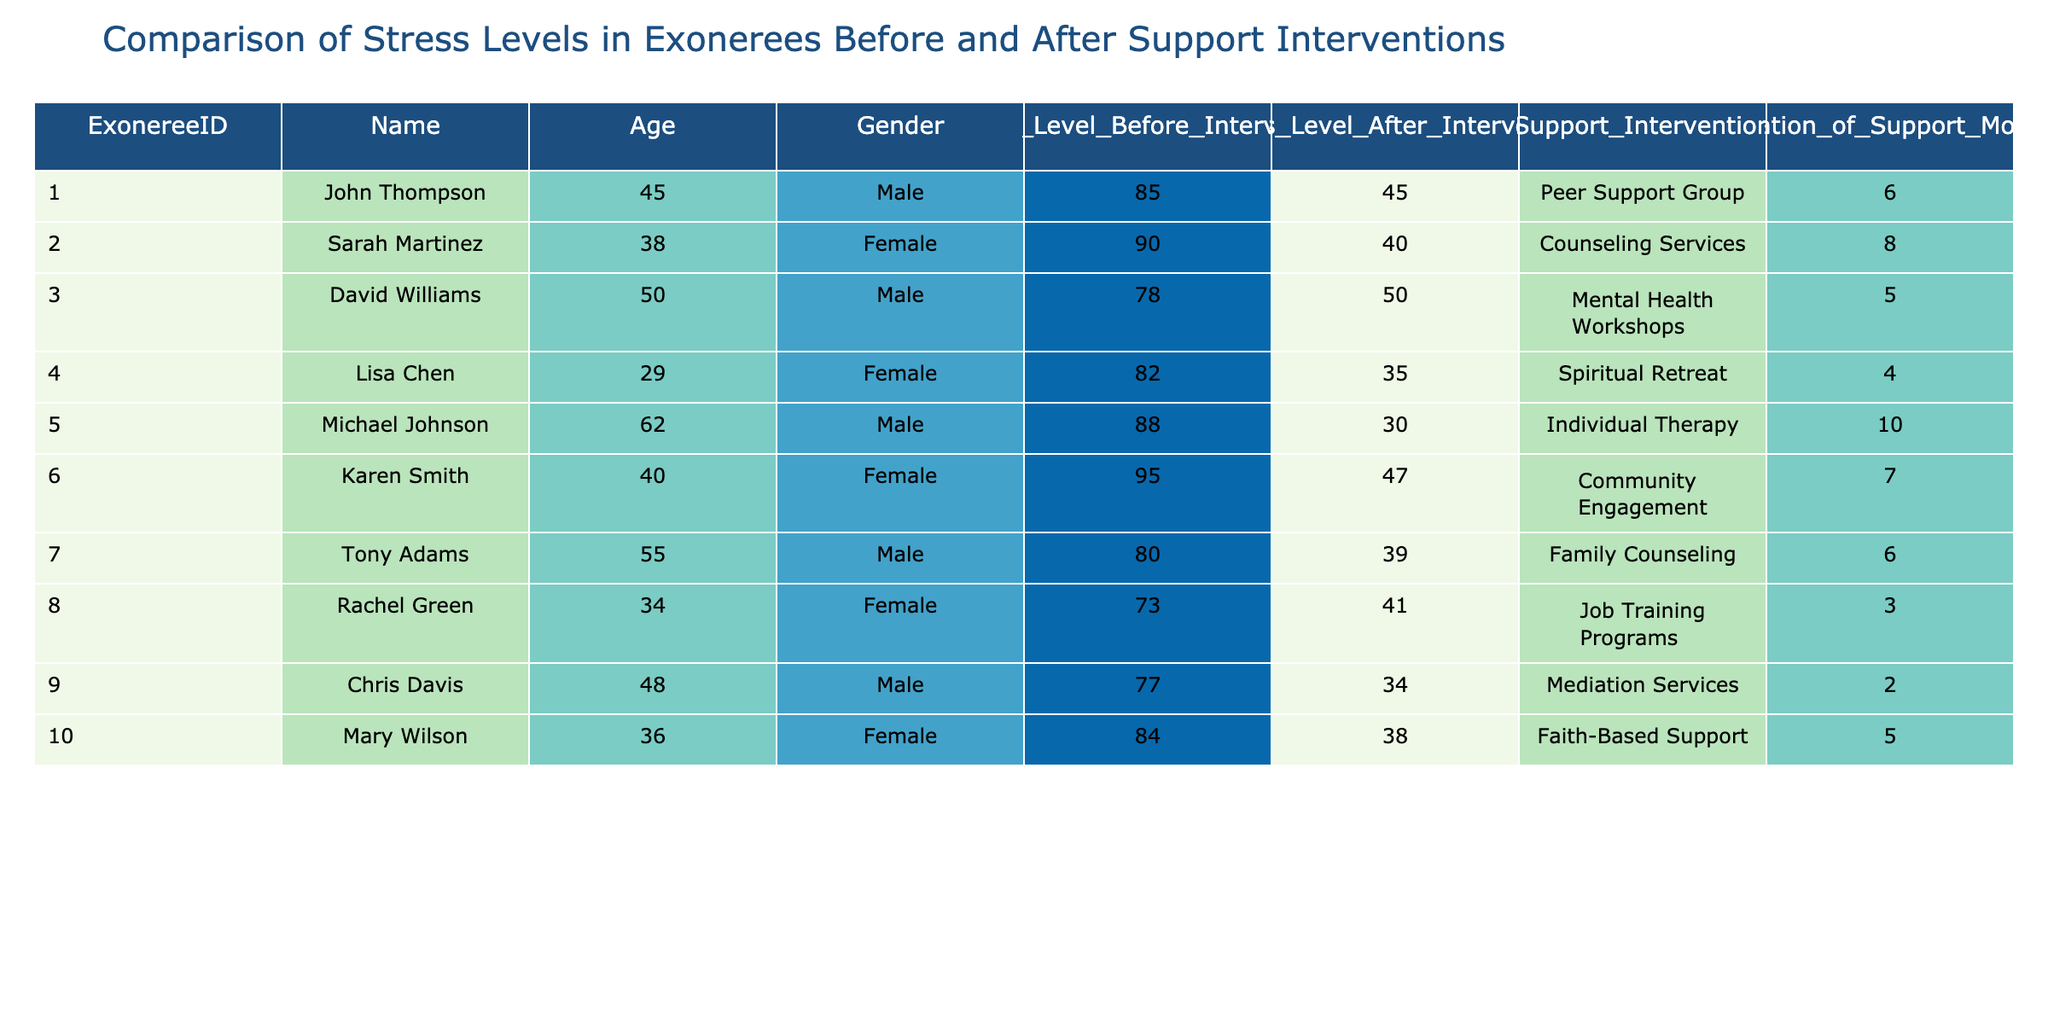What was John Thompson's stress level before the intervention? John Thompson's stress level before the intervention can be found in the "Stress_Level_Before_Intervention" column corresponding to his row in the table. His stress level is 85.
Answer: 85 What support intervention did Sarah Martinez receive? To find out the support intervention for Sarah Martinez, we look under the "Support_Intervention" column in her row. She received Counseling Services.
Answer: Counseling Services How much did Michael Johnson's stress level decrease after intervention? To determine how much Michael Johnson's stress level decreased, we subtract his "Stress_Level_After_Intervention" (30) from his "Stress_Level_Before_Intervention" (88). The difference is 88 - 30 = 58.
Answer: 58 Which exoneree experienced the lowest stress level after the intervention, and what was it? We need to look at the "Stress_Level_After_Intervention" column and find the minimum value. The lowest is for Michael Johnson at 30.
Answer: Michael Johnson, 30 Is there any exoneree whose stress level did not improve after the support intervention? We check the "Stress_Level_Before_Intervention" and "Stress_Level_After_Intervention" for each exoneree to see if any have stress levels that are the same or higher after the intervention. Chris Davis did not improve, going from 77 to 34.
Answer: Yes What is the average stress level of exonerees before the intervention? We calculate the average by summing the "Stress_Level_Before_Intervention" values for all exonerees: (85 + 90 + 78 + 82 + 88 + 95 + 80 + 73 + 77 + 84) = 837. There are 10 exonerees, so the average is 837 / 10 = 83.7.
Answer: 83.7 Did any female exonerees achieve a stress level below 40 after the intervention? To answer this, we must look at the "Stress_Level_After_Intervention" for all female exonerees (Sarah Martinez, Lisa Chen, Karen Smith, and Mary Wilson). The only one who achieved a level below 40 is Lisa Chen with a level of 35.
Answer: Yes Who had the longest duration of support months and what type of support did they receive? We need to look at the "Duration_of_Support_Months" column to find the highest value. Michael Johnson had the longest duration at 10 months, with Individual Therapy as his support type.
Answer: Michael Johnson, Individual Therapy 